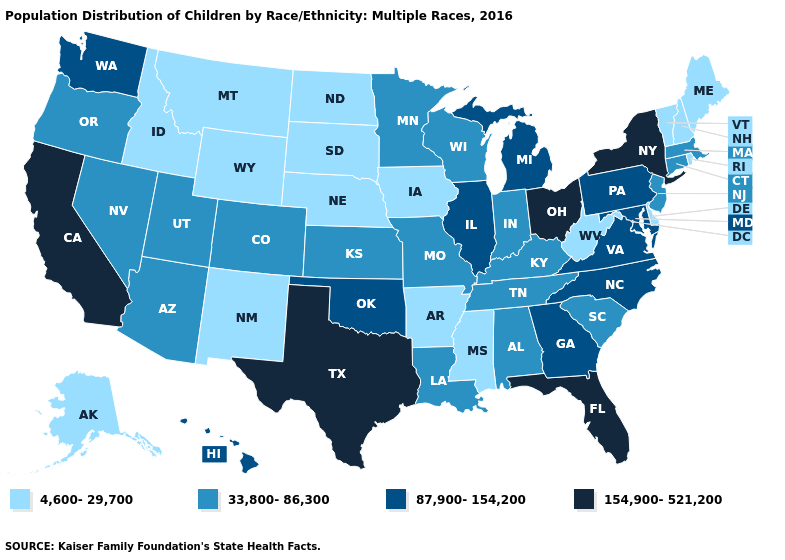Does Kansas have the same value as South Dakota?
Give a very brief answer. No. Does Massachusetts have the lowest value in the Northeast?
Concise answer only. No. Name the states that have a value in the range 33,800-86,300?
Be succinct. Alabama, Arizona, Colorado, Connecticut, Indiana, Kansas, Kentucky, Louisiana, Massachusetts, Minnesota, Missouri, Nevada, New Jersey, Oregon, South Carolina, Tennessee, Utah, Wisconsin. Name the states that have a value in the range 33,800-86,300?
Write a very short answer. Alabama, Arizona, Colorado, Connecticut, Indiana, Kansas, Kentucky, Louisiana, Massachusetts, Minnesota, Missouri, Nevada, New Jersey, Oregon, South Carolina, Tennessee, Utah, Wisconsin. Does the map have missing data?
Write a very short answer. No. What is the value of Indiana?
Give a very brief answer. 33,800-86,300. What is the value of New Hampshire?
Concise answer only. 4,600-29,700. Which states hav the highest value in the MidWest?
Keep it brief. Ohio. Name the states that have a value in the range 87,900-154,200?
Quick response, please. Georgia, Hawaii, Illinois, Maryland, Michigan, North Carolina, Oklahoma, Pennsylvania, Virginia, Washington. Name the states that have a value in the range 154,900-521,200?
Keep it brief. California, Florida, New York, Ohio, Texas. Name the states that have a value in the range 154,900-521,200?
Concise answer only. California, Florida, New York, Ohio, Texas. Does New Jersey have the lowest value in the Northeast?
Keep it brief. No. Name the states that have a value in the range 4,600-29,700?
Answer briefly. Alaska, Arkansas, Delaware, Idaho, Iowa, Maine, Mississippi, Montana, Nebraska, New Hampshire, New Mexico, North Dakota, Rhode Island, South Dakota, Vermont, West Virginia, Wyoming. What is the highest value in the South ?
Give a very brief answer. 154,900-521,200. Name the states that have a value in the range 33,800-86,300?
Be succinct. Alabama, Arizona, Colorado, Connecticut, Indiana, Kansas, Kentucky, Louisiana, Massachusetts, Minnesota, Missouri, Nevada, New Jersey, Oregon, South Carolina, Tennessee, Utah, Wisconsin. 